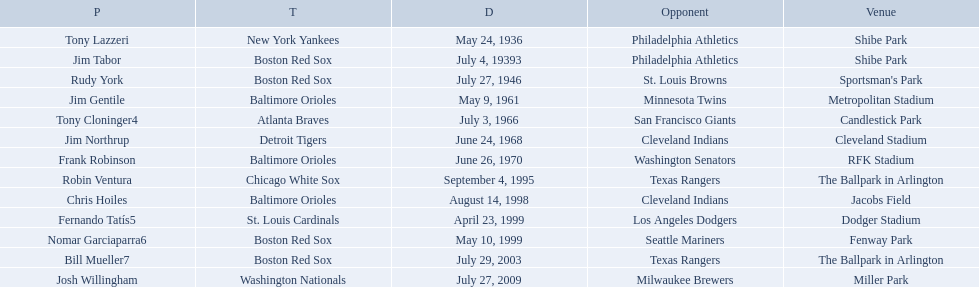What are the names of all the players? Tony Lazzeri, Jim Tabor, Rudy York, Jim Gentile, Tony Cloninger4, Jim Northrup, Frank Robinson, Robin Ventura, Chris Hoiles, Fernando Tatís5, Nomar Garciaparra6, Bill Mueller7, Josh Willingham. What are the names of all the teams holding home run records? New York Yankees, Boston Red Sox, Baltimore Orioles, Atlanta Braves, Detroit Tigers, Chicago White Sox, St. Louis Cardinals, Washington Nationals. Which player played for the new york yankees? Tony Lazzeri. What are the dates? May 24, 1936, July 4, 19393, July 27, 1946, May 9, 1961, July 3, 1966, June 24, 1968, June 26, 1970, September 4, 1995, August 14, 1998, April 23, 1999, May 10, 1999, July 29, 2003, July 27, 2009. Which date is in 1936? May 24, 1936. What player is listed for this date? Tony Lazzeri. Who were all of the players? Tony Lazzeri, Jim Tabor, Rudy York, Jim Gentile, Tony Cloninger4, Jim Northrup, Frank Robinson, Robin Ventura, Chris Hoiles, Fernando Tatís5, Nomar Garciaparra6, Bill Mueller7, Josh Willingham. What year was there a player for the yankees? May 24, 1936. What was the name of that 1936 yankees player? Tony Lazzeri. 